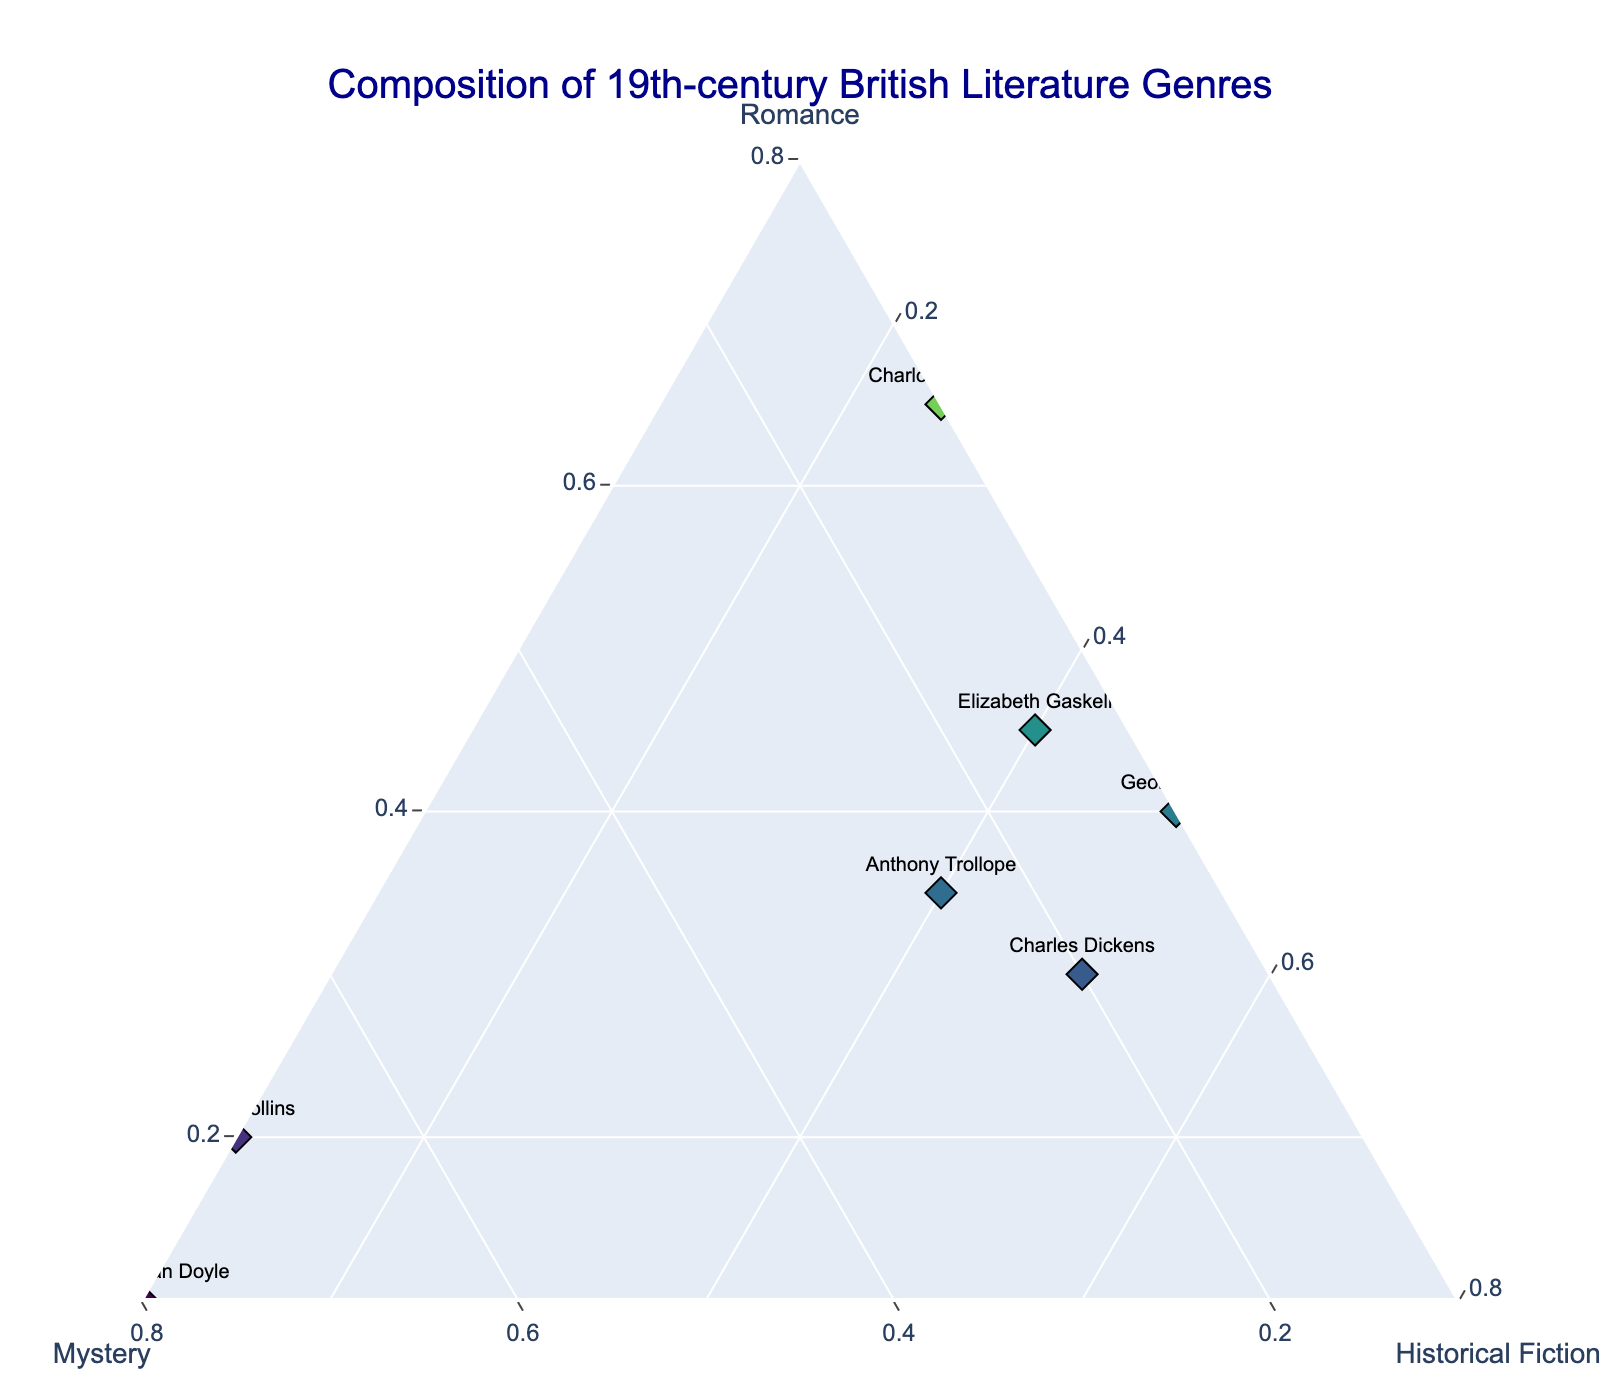Who has the highest percentage of romance in their literature? By looking at the plot, the author with the data point furthest along the Romance axis is Jane Austen.
Answer: Jane Austen Which author focuses most on the mystery genre? Observing the points along the Mystery axis, Arthur Conan Doyle's data point is furthest along this axis.
Answer: Arthur Conan Doyle Which author divides their literary composition equally across all genres? To divide equally, an author's data point would be centrally located in the ternary plot; however, no author's composition is evenly split.
Answer: None Who is the author with the highest percentage of historical fiction? Looking at the Historical Fiction axis, Sir Walter Scott has the data point furthest along this axis.
Answer: Sir Walter Scott Out of Jane Austen and Wilkie Collins, who has a higher percentage of romance in their works? Comparing the data points, Jane Austen's point is significantly further along the Romance axis than Wilkie Collins' point.
Answer: Jane Austen Which author has a similar genre distribution to Elizabeth Gaskell? Examining the proximity of the data points, Anthony Trollope’s point is closest to Elizabeth Gaskell's, indicating they have similar genre distributions.
Answer: Anthony Trollope Is there any author who has an equal percentage of romance and historical fiction but no mystery? No data points exist on the plot that have both equal romance and historical fiction percentages without any mystery.
Answer: None How many authors have more than 50% of their work classified as historical fiction? Looking at the data points along the Historical Fiction axis, there are three authors: Sir Walter Scott, Charles Dickens, and George Eliot.
Answer: Three Which author has the most balanced composition between mystery and historical fiction? Examining the Mystery and Historical Fiction axes, Charles Dickens has a relatively balanced composition with 20% mystery and 50% historical fiction.
Answer: Charles Dickens Which author has the least presence of romance in their works? The author closest to the origin of the Romance axis is Arthur Conan Doyle, with only 10% romance.
Answer: Arthur Conan Doyle 